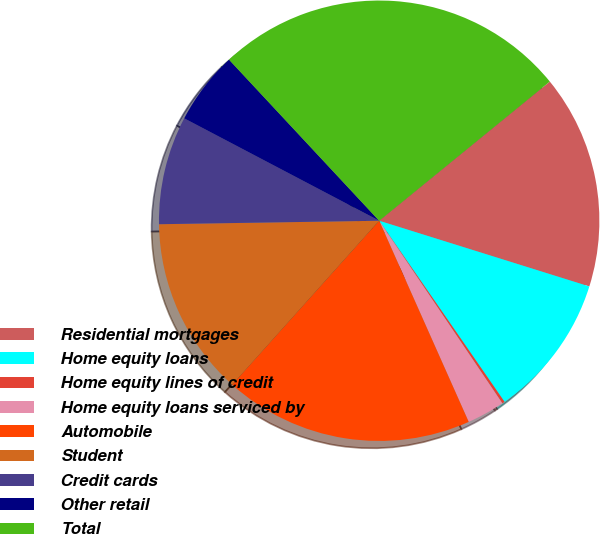Convert chart. <chart><loc_0><loc_0><loc_500><loc_500><pie_chart><fcel>Residential mortgages<fcel>Home equity loans<fcel>Home equity lines of credit<fcel>Home equity loans serviced by<fcel>Automobile<fcel>Student<fcel>Credit cards<fcel>Other retail<fcel>Total<nl><fcel>15.71%<fcel>10.54%<fcel>0.19%<fcel>2.78%<fcel>18.29%<fcel>13.12%<fcel>7.95%<fcel>5.36%<fcel>26.05%<nl></chart> 